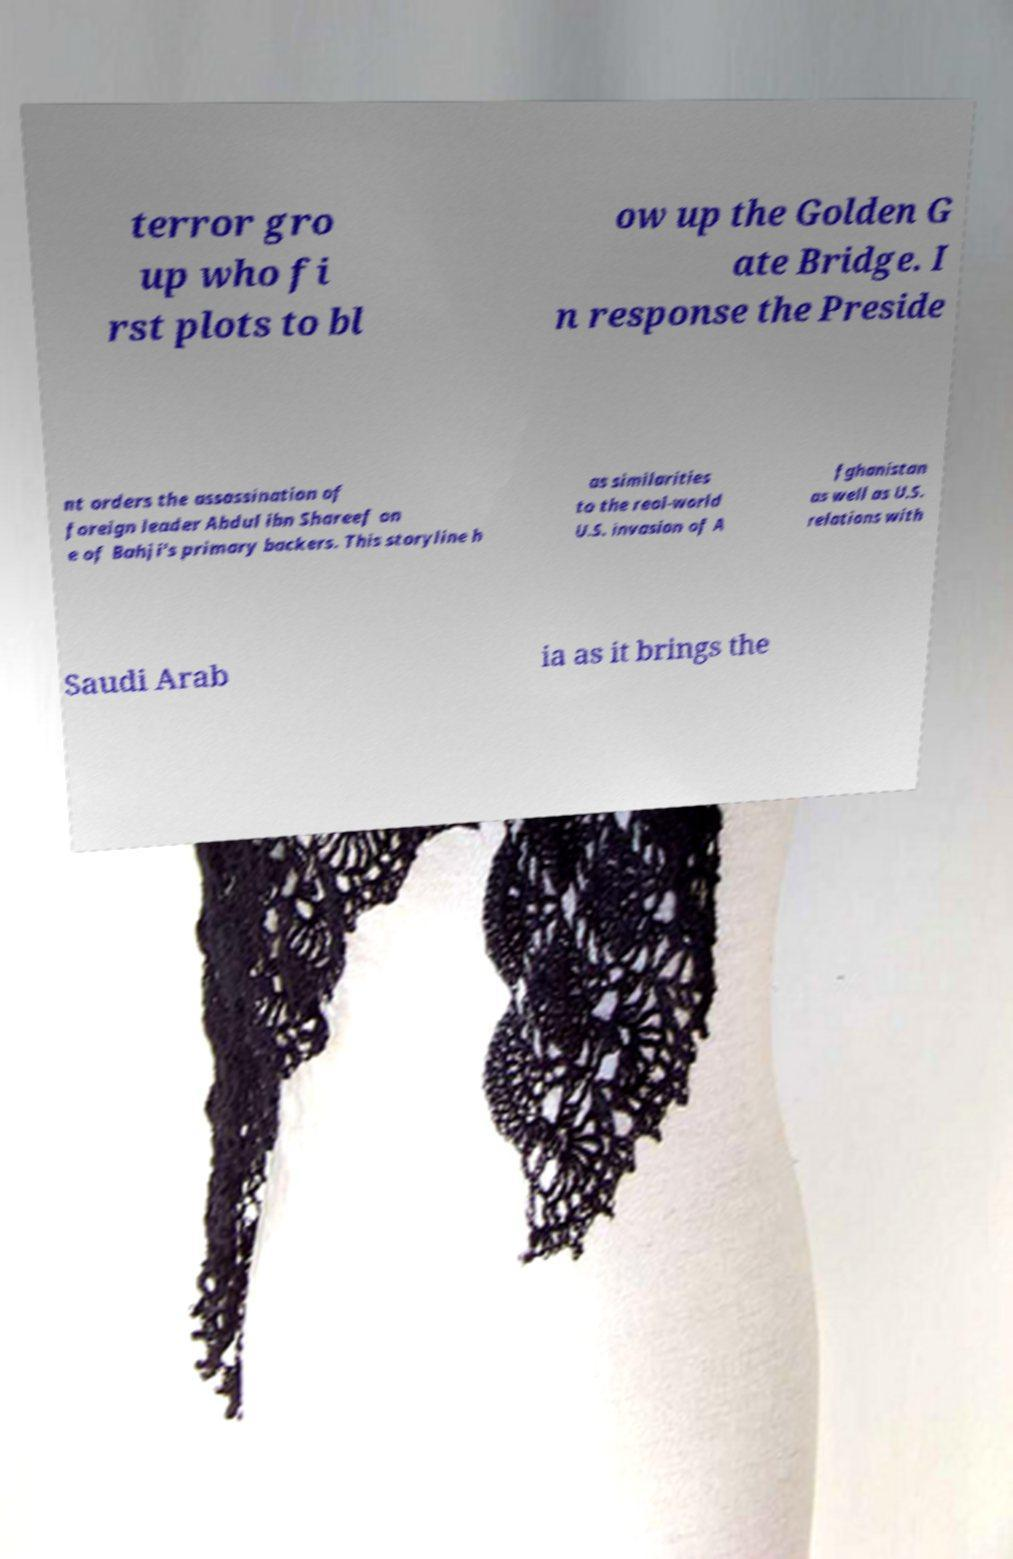Can you accurately transcribe the text from the provided image for me? terror gro up who fi rst plots to bl ow up the Golden G ate Bridge. I n response the Preside nt orders the assassination of foreign leader Abdul ibn Shareef on e of Bahji's primary backers. This storyline h as similarities to the real-world U.S. invasion of A fghanistan as well as U.S. relations with Saudi Arab ia as it brings the 